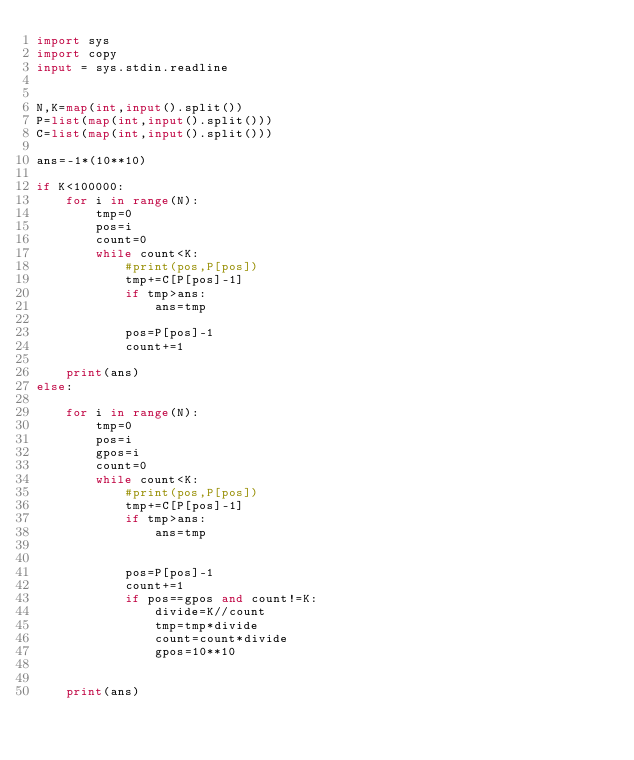Convert code to text. <code><loc_0><loc_0><loc_500><loc_500><_Python_>import sys
import copy
input = sys.stdin.readline


N,K=map(int,input().split())
P=list(map(int,input().split()))
C=list(map(int,input().split()))

ans=-1*(10**10)

if K<100000:
    for i in range(N):
        tmp=0
        pos=i
        count=0
        while count<K:    
            #print(pos,P[pos])
            tmp+=C[P[pos]-1]
            if tmp>ans:
                ans=tmp
            
            pos=P[pos]-1
            count+=1
     
    print(ans)
else:
    
    for i in range(N):
        tmp=0
        pos=i
        gpos=i
        count=0
        while count<K:    
            #print(pos,P[pos])
            tmp+=C[P[pos]-1]
            if tmp>ans:
                ans=tmp
            
            
            pos=P[pos]-1
            count+=1
            if pos==gpos and count!=K:
                divide=K//count
                tmp=tmp*divide
                count=count*divide
                gpos=10**10
            
    
    print(ans)</code> 